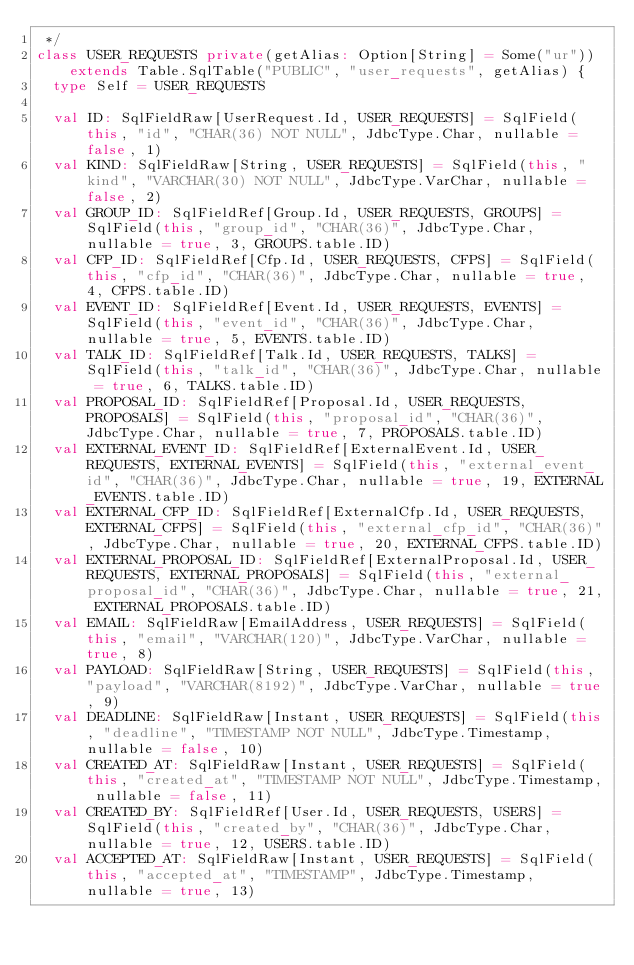Convert code to text. <code><loc_0><loc_0><loc_500><loc_500><_Scala_> */
class USER_REQUESTS private(getAlias: Option[String] = Some("ur")) extends Table.SqlTable("PUBLIC", "user_requests", getAlias) {
  type Self = USER_REQUESTS

  val ID: SqlFieldRaw[UserRequest.Id, USER_REQUESTS] = SqlField(this, "id", "CHAR(36) NOT NULL", JdbcType.Char, nullable = false, 1)
  val KIND: SqlFieldRaw[String, USER_REQUESTS] = SqlField(this, "kind", "VARCHAR(30) NOT NULL", JdbcType.VarChar, nullable = false, 2)
  val GROUP_ID: SqlFieldRef[Group.Id, USER_REQUESTS, GROUPS] = SqlField(this, "group_id", "CHAR(36)", JdbcType.Char, nullable = true, 3, GROUPS.table.ID)
  val CFP_ID: SqlFieldRef[Cfp.Id, USER_REQUESTS, CFPS] = SqlField(this, "cfp_id", "CHAR(36)", JdbcType.Char, nullable = true, 4, CFPS.table.ID)
  val EVENT_ID: SqlFieldRef[Event.Id, USER_REQUESTS, EVENTS] = SqlField(this, "event_id", "CHAR(36)", JdbcType.Char, nullable = true, 5, EVENTS.table.ID)
  val TALK_ID: SqlFieldRef[Talk.Id, USER_REQUESTS, TALKS] = SqlField(this, "talk_id", "CHAR(36)", JdbcType.Char, nullable = true, 6, TALKS.table.ID)
  val PROPOSAL_ID: SqlFieldRef[Proposal.Id, USER_REQUESTS, PROPOSALS] = SqlField(this, "proposal_id", "CHAR(36)", JdbcType.Char, nullable = true, 7, PROPOSALS.table.ID)
  val EXTERNAL_EVENT_ID: SqlFieldRef[ExternalEvent.Id, USER_REQUESTS, EXTERNAL_EVENTS] = SqlField(this, "external_event_id", "CHAR(36)", JdbcType.Char, nullable = true, 19, EXTERNAL_EVENTS.table.ID)
  val EXTERNAL_CFP_ID: SqlFieldRef[ExternalCfp.Id, USER_REQUESTS, EXTERNAL_CFPS] = SqlField(this, "external_cfp_id", "CHAR(36)", JdbcType.Char, nullable = true, 20, EXTERNAL_CFPS.table.ID)
  val EXTERNAL_PROPOSAL_ID: SqlFieldRef[ExternalProposal.Id, USER_REQUESTS, EXTERNAL_PROPOSALS] = SqlField(this, "external_proposal_id", "CHAR(36)", JdbcType.Char, nullable = true, 21, EXTERNAL_PROPOSALS.table.ID)
  val EMAIL: SqlFieldRaw[EmailAddress, USER_REQUESTS] = SqlField(this, "email", "VARCHAR(120)", JdbcType.VarChar, nullable = true, 8)
  val PAYLOAD: SqlFieldRaw[String, USER_REQUESTS] = SqlField(this, "payload", "VARCHAR(8192)", JdbcType.VarChar, nullable = true, 9)
  val DEADLINE: SqlFieldRaw[Instant, USER_REQUESTS] = SqlField(this, "deadline", "TIMESTAMP NOT NULL", JdbcType.Timestamp, nullable = false, 10)
  val CREATED_AT: SqlFieldRaw[Instant, USER_REQUESTS] = SqlField(this, "created_at", "TIMESTAMP NOT NULL", JdbcType.Timestamp, nullable = false, 11)
  val CREATED_BY: SqlFieldRef[User.Id, USER_REQUESTS, USERS] = SqlField(this, "created_by", "CHAR(36)", JdbcType.Char, nullable = true, 12, USERS.table.ID)
  val ACCEPTED_AT: SqlFieldRaw[Instant, USER_REQUESTS] = SqlField(this, "accepted_at", "TIMESTAMP", JdbcType.Timestamp, nullable = true, 13)</code> 